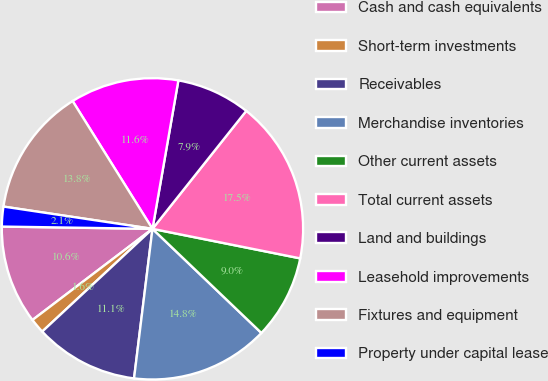Convert chart to OTSL. <chart><loc_0><loc_0><loc_500><loc_500><pie_chart><fcel>Cash and cash equivalents<fcel>Short-term investments<fcel>Receivables<fcel>Merchandise inventories<fcel>Other current assets<fcel>Total current assets<fcel>Land and buildings<fcel>Leasehold improvements<fcel>Fixtures and equipment<fcel>Property under capital lease<nl><fcel>10.58%<fcel>1.6%<fcel>11.11%<fcel>14.81%<fcel>9.0%<fcel>17.45%<fcel>7.94%<fcel>11.64%<fcel>13.75%<fcel>2.12%<nl></chart> 